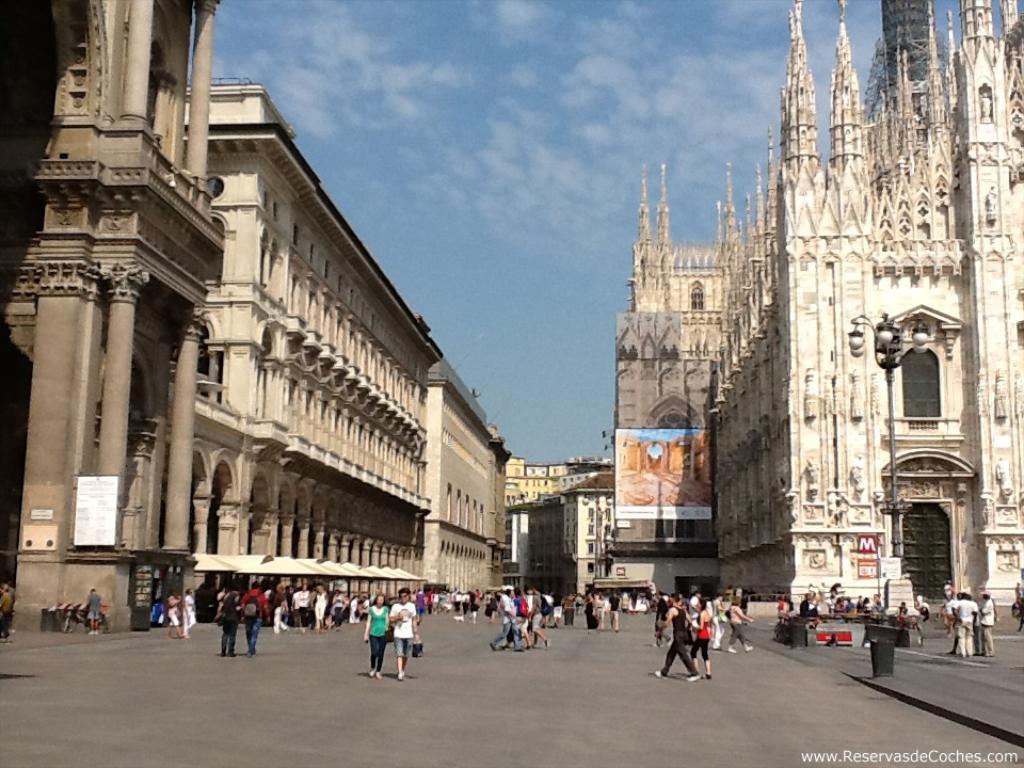How would you summarize this image in a sentence or two? In this image, we can see a crowd in between buildings. There are some persons standing in front of the building. There is a screen in the middle of the image. In the background of the image, there is a sky. 